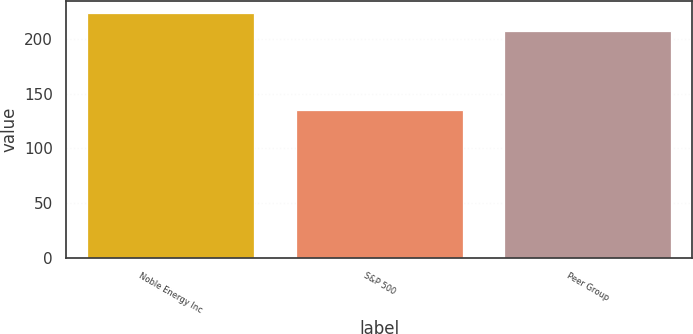Convert chart. <chart><loc_0><loc_0><loc_500><loc_500><bar_chart><fcel>Noble Energy Inc<fcel>S&P 500<fcel>Peer Group<nl><fcel>223.97<fcel>134.7<fcel>207.03<nl></chart> 